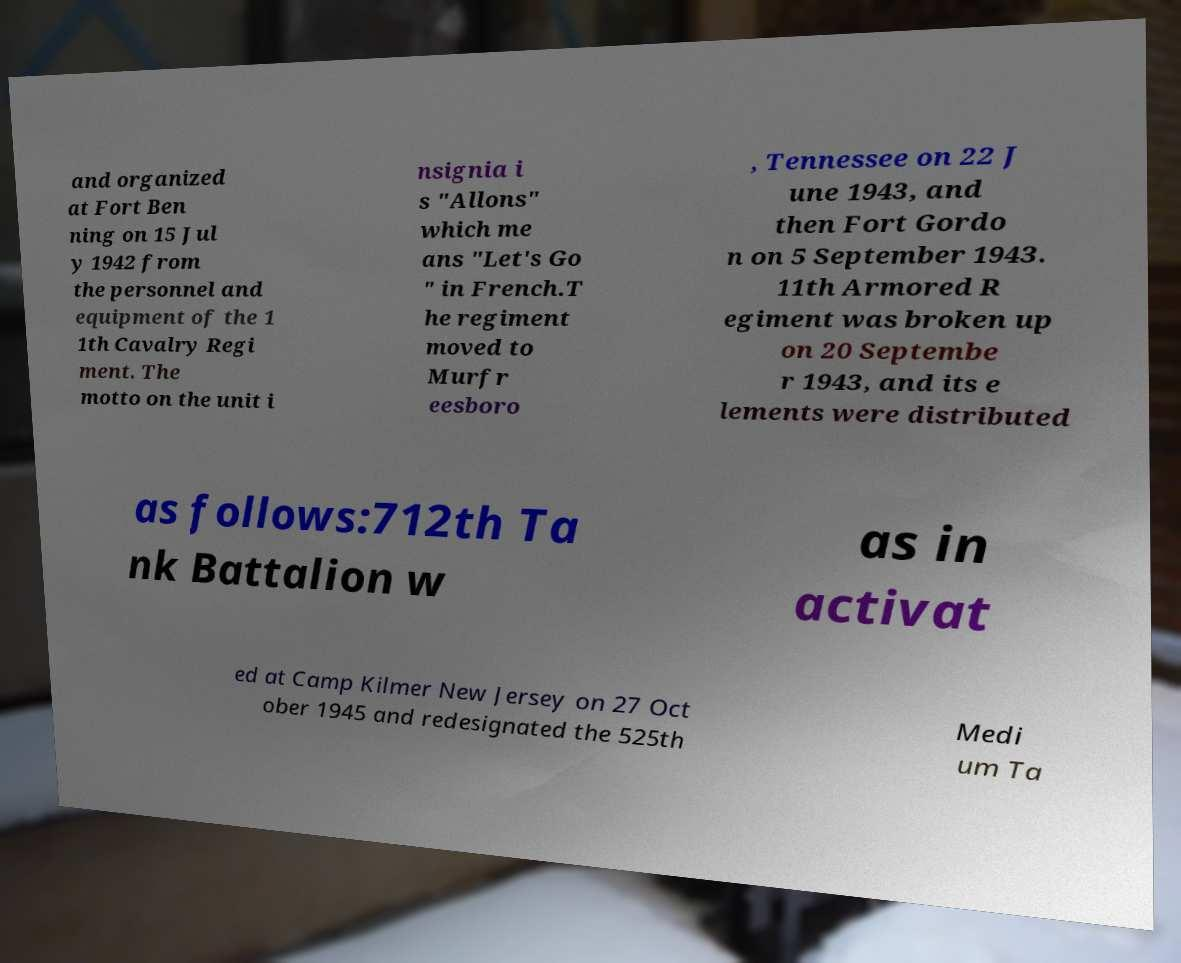Please read and relay the text visible in this image. What does it say? and organized at Fort Ben ning on 15 Jul y 1942 from the personnel and equipment of the 1 1th Cavalry Regi ment. The motto on the unit i nsignia i s "Allons" which me ans "Let's Go " in French.T he regiment moved to Murfr eesboro , Tennessee on 22 J une 1943, and then Fort Gordo n on 5 September 1943. 11th Armored R egiment was broken up on 20 Septembe r 1943, and its e lements were distributed as follows:712th Ta nk Battalion w as in activat ed at Camp Kilmer New Jersey on 27 Oct ober 1945 and redesignated the 525th Medi um Ta 